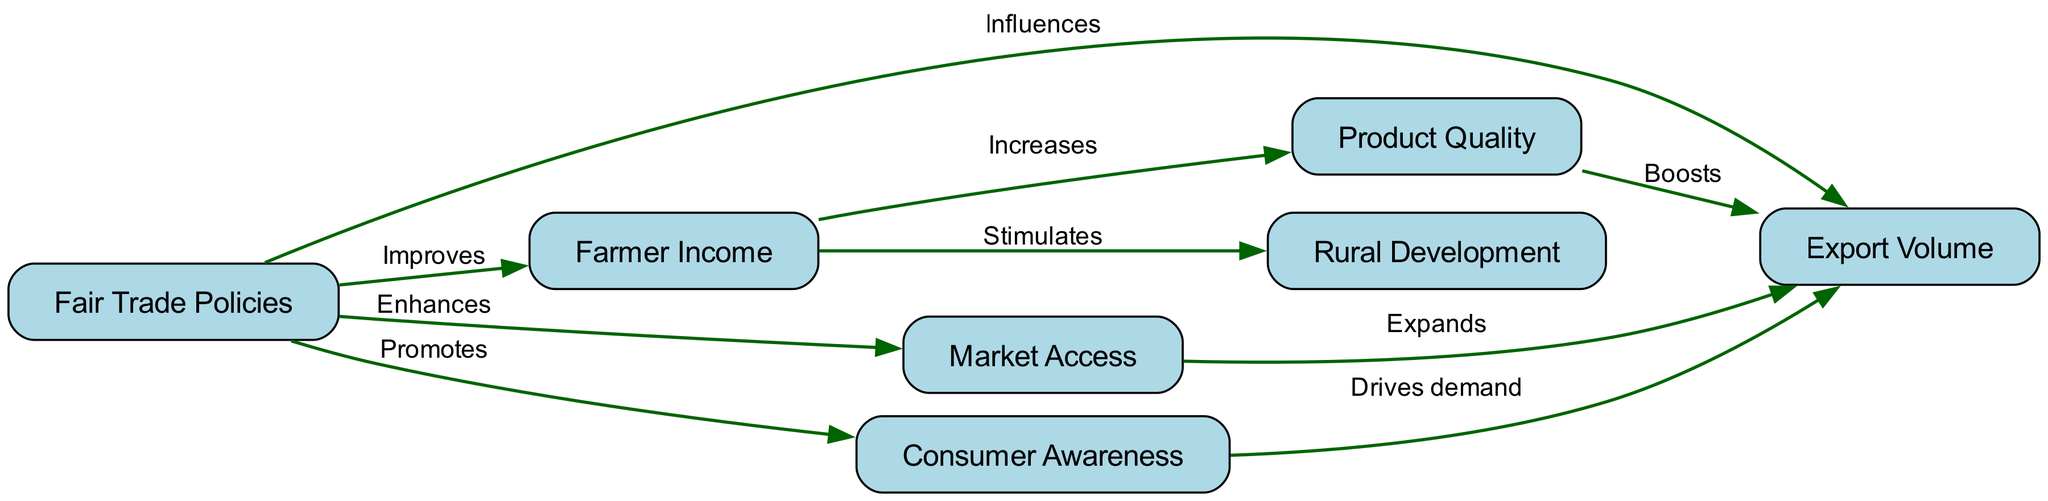What is the total number of nodes in the diagram? The diagram lists the nodes under the "nodes" key, which contains entries for Fair Trade Policies, Export Volume, Farmer Income, Product Quality, Market Access, Rural Development, and Consumer Awareness. Counting these entries gives us a total of seven nodes.
Answer: 7 Which node influences Export Volume? The diagram specifies that "Fair Trade Policies" directly influences "Export Volume," indicating a one-way relationship in which fair trade policies affect the volume of exports.
Answer: Fair Trade Policies What does Farmer Income stimulate? According to the relationships shown in the diagram, "Farmer Income" is linked to "Rural Development," showing that an increase in farmer income contributes to improvements in rural development.
Answer: Rural Development What label describes the edge from Product Quality to Export Volume? The edge connecting "Product Quality" to "Export Volume" is marked with the label "Boosts," indicating that increases in product quality have a positive effect on the export volume.
Answer: Boosts Which node is driven by Consumer Awareness? The diagram indicates that "Consumer Awareness" drives demand for "Export Volume," showing that higher awareness among consumers leads to increased demand for exports.
Answer: Export Volume What enhances Market Access? The relationship in the diagram shows that "Fair Trade Policies" enhance "Market Access," meaning that the implementation of these policies leads to better opportunities for accessing markets.
Answer: Market Access How many edges are in the diagram? To determine the total number of edges, we examine the list under the "edges" key, where connections between nodes such as influences, improves, and enhances are specified. Adding these together reveals that there are nine edges.
Answer: 9 What increases Product Quality? The diagram indicates that "Farmer Income" increases "Product Quality," showing that as farmer income improves, so does the quality of the products they offer.
Answer: Farmer Income Which node receives demand from Consumer Awareness? The diagram illustrates that "Export Volume" receives demand driven by "Consumer Awareness," demonstrating that a more informed consumer base positively impacts export volumes.
Answer: Export Volume 